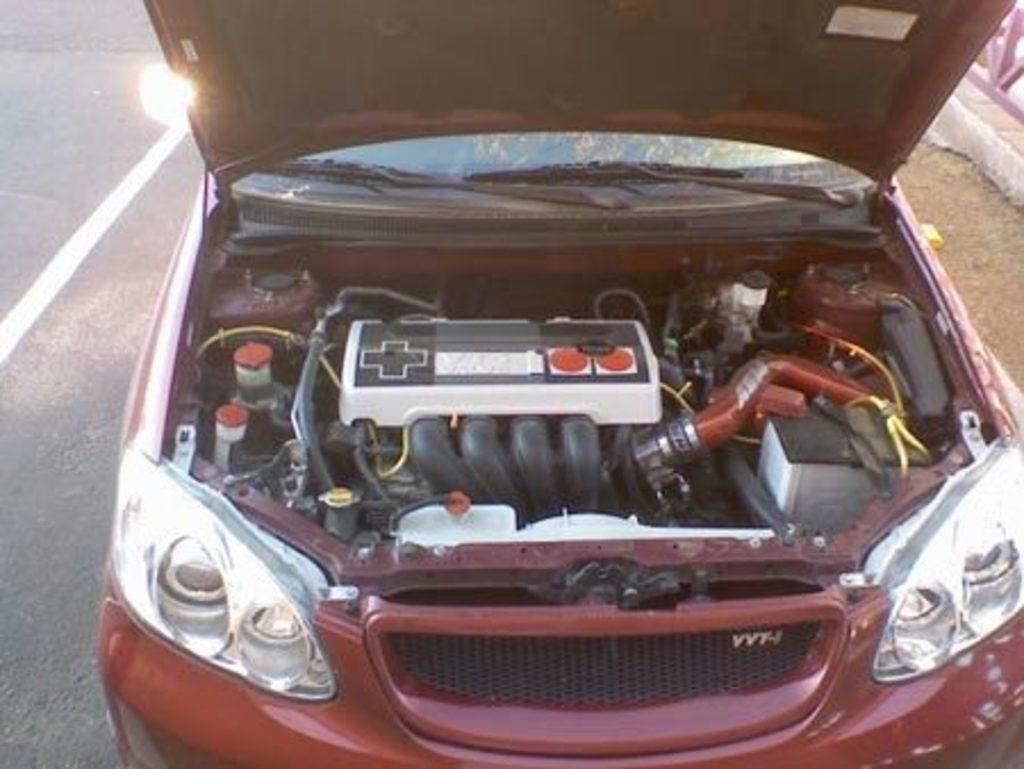What is the main subject of the image? The main subject of the image is a car on the road. Can you describe any specific details about the car? Yes, there is an engine part of the car visible in the image. What can be seen at the side of the road in the image? There appears to be a fence at the side of the road in the image. What type of music can be heard coming from the car in the image? There is no indication of any music in the image, as it only shows a car on the road with a visible engine part and a fence at the side of the road. 